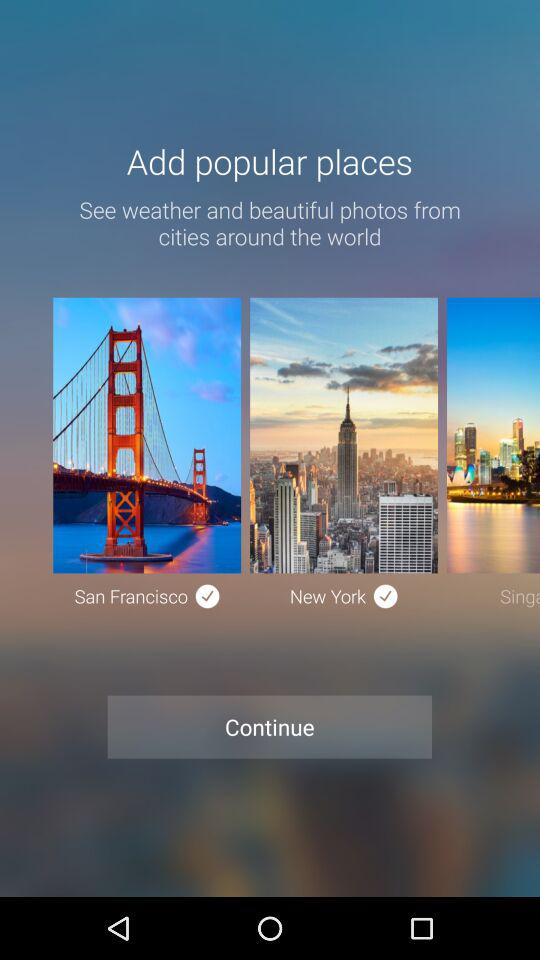Which city has been added? The added cities are San Francisco and New York. 